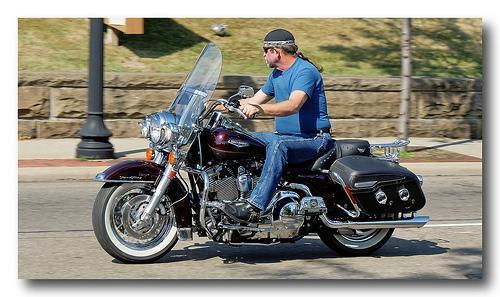How many motorcycles are there?
Give a very brief answer. 1. 